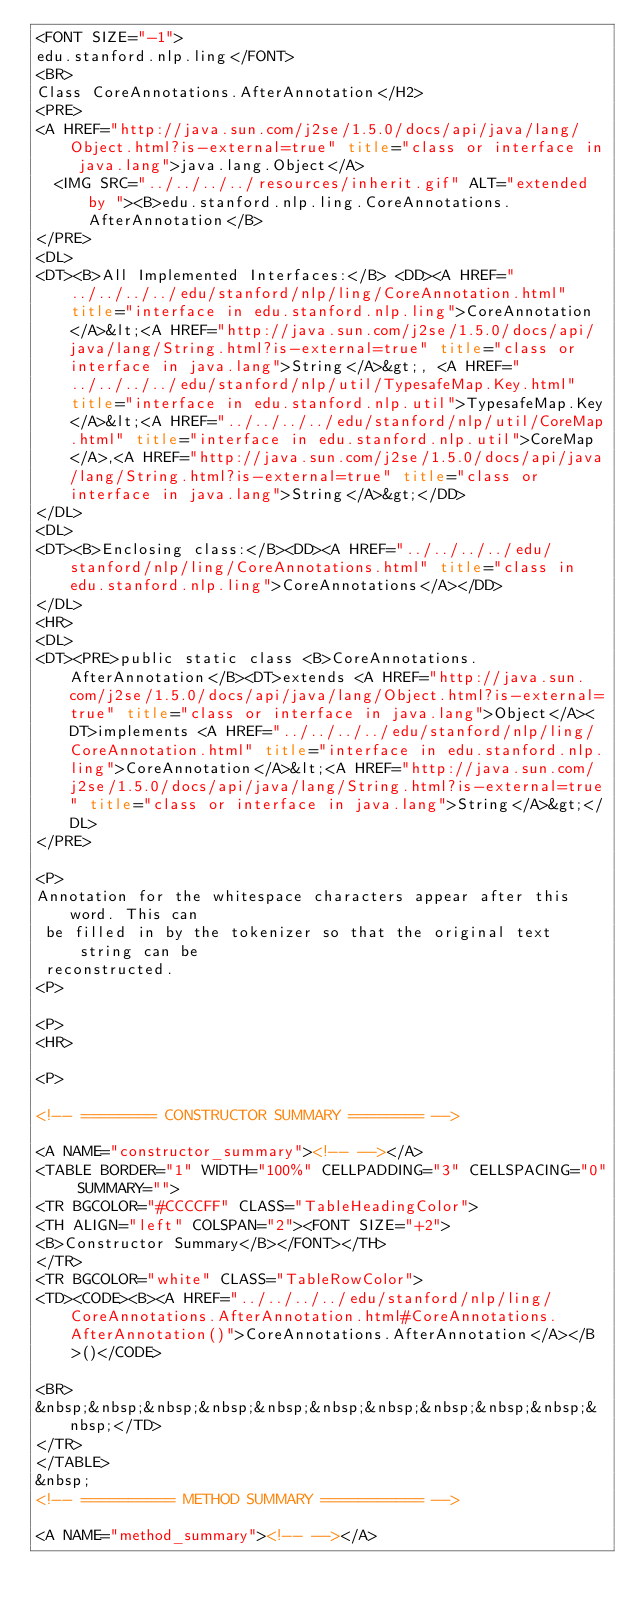<code> <loc_0><loc_0><loc_500><loc_500><_HTML_><FONT SIZE="-1">
edu.stanford.nlp.ling</FONT>
<BR>
Class CoreAnnotations.AfterAnnotation</H2>
<PRE>
<A HREF="http://java.sun.com/j2se/1.5.0/docs/api/java/lang/Object.html?is-external=true" title="class or interface in java.lang">java.lang.Object</A>
  <IMG SRC="../../../../resources/inherit.gif" ALT="extended by "><B>edu.stanford.nlp.ling.CoreAnnotations.AfterAnnotation</B>
</PRE>
<DL>
<DT><B>All Implemented Interfaces:</B> <DD><A HREF="../../../../edu/stanford/nlp/ling/CoreAnnotation.html" title="interface in edu.stanford.nlp.ling">CoreAnnotation</A>&lt;<A HREF="http://java.sun.com/j2se/1.5.0/docs/api/java/lang/String.html?is-external=true" title="class or interface in java.lang">String</A>&gt;, <A HREF="../../../../edu/stanford/nlp/util/TypesafeMap.Key.html" title="interface in edu.stanford.nlp.util">TypesafeMap.Key</A>&lt;<A HREF="../../../../edu/stanford/nlp/util/CoreMap.html" title="interface in edu.stanford.nlp.util">CoreMap</A>,<A HREF="http://java.sun.com/j2se/1.5.0/docs/api/java/lang/String.html?is-external=true" title="class or interface in java.lang">String</A>&gt;</DD>
</DL>
<DL>
<DT><B>Enclosing class:</B><DD><A HREF="../../../../edu/stanford/nlp/ling/CoreAnnotations.html" title="class in edu.stanford.nlp.ling">CoreAnnotations</A></DD>
</DL>
<HR>
<DL>
<DT><PRE>public static class <B>CoreAnnotations.AfterAnnotation</B><DT>extends <A HREF="http://java.sun.com/j2se/1.5.0/docs/api/java/lang/Object.html?is-external=true" title="class or interface in java.lang">Object</A><DT>implements <A HREF="../../../../edu/stanford/nlp/ling/CoreAnnotation.html" title="interface in edu.stanford.nlp.ling">CoreAnnotation</A>&lt;<A HREF="http://java.sun.com/j2se/1.5.0/docs/api/java/lang/String.html?is-external=true" title="class or interface in java.lang">String</A>&gt;</DL>
</PRE>

<P>
Annotation for the whitespace characters appear after this word. This can
 be filled in by the tokenizer so that the original text string can be
 reconstructed.
<P>

<P>
<HR>

<P>

<!-- ======== CONSTRUCTOR SUMMARY ======== -->

<A NAME="constructor_summary"><!-- --></A>
<TABLE BORDER="1" WIDTH="100%" CELLPADDING="3" CELLSPACING="0" SUMMARY="">
<TR BGCOLOR="#CCCCFF" CLASS="TableHeadingColor">
<TH ALIGN="left" COLSPAN="2"><FONT SIZE="+2">
<B>Constructor Summary</B></FONT></TH>
</TR>
<TR BGCOLOR="white" CLASS="TableRowColor">
<TD><CODE><B><A HREF="../../../../edu/stanford/nlp/ling/CoreAnnotations.AfterAnnotation.html#CoreAnnotations.AfterAnnotation()">CoreAnnotations.AfterAnnotation</A></B>()</CODE>

<BR>
&nbsp;&nbsp;&nbsp;&nbsp;&nbsp;&nbsp;&nbsp;&nbsp;&nbsp;&nbsp;&nbsp;</TD>
</TR>
</TABLE>
&nbsp;
<!-- ========== METHOD SUMMARY =========== -->

<A NAME="method_summary"><!-- --></A></code> 